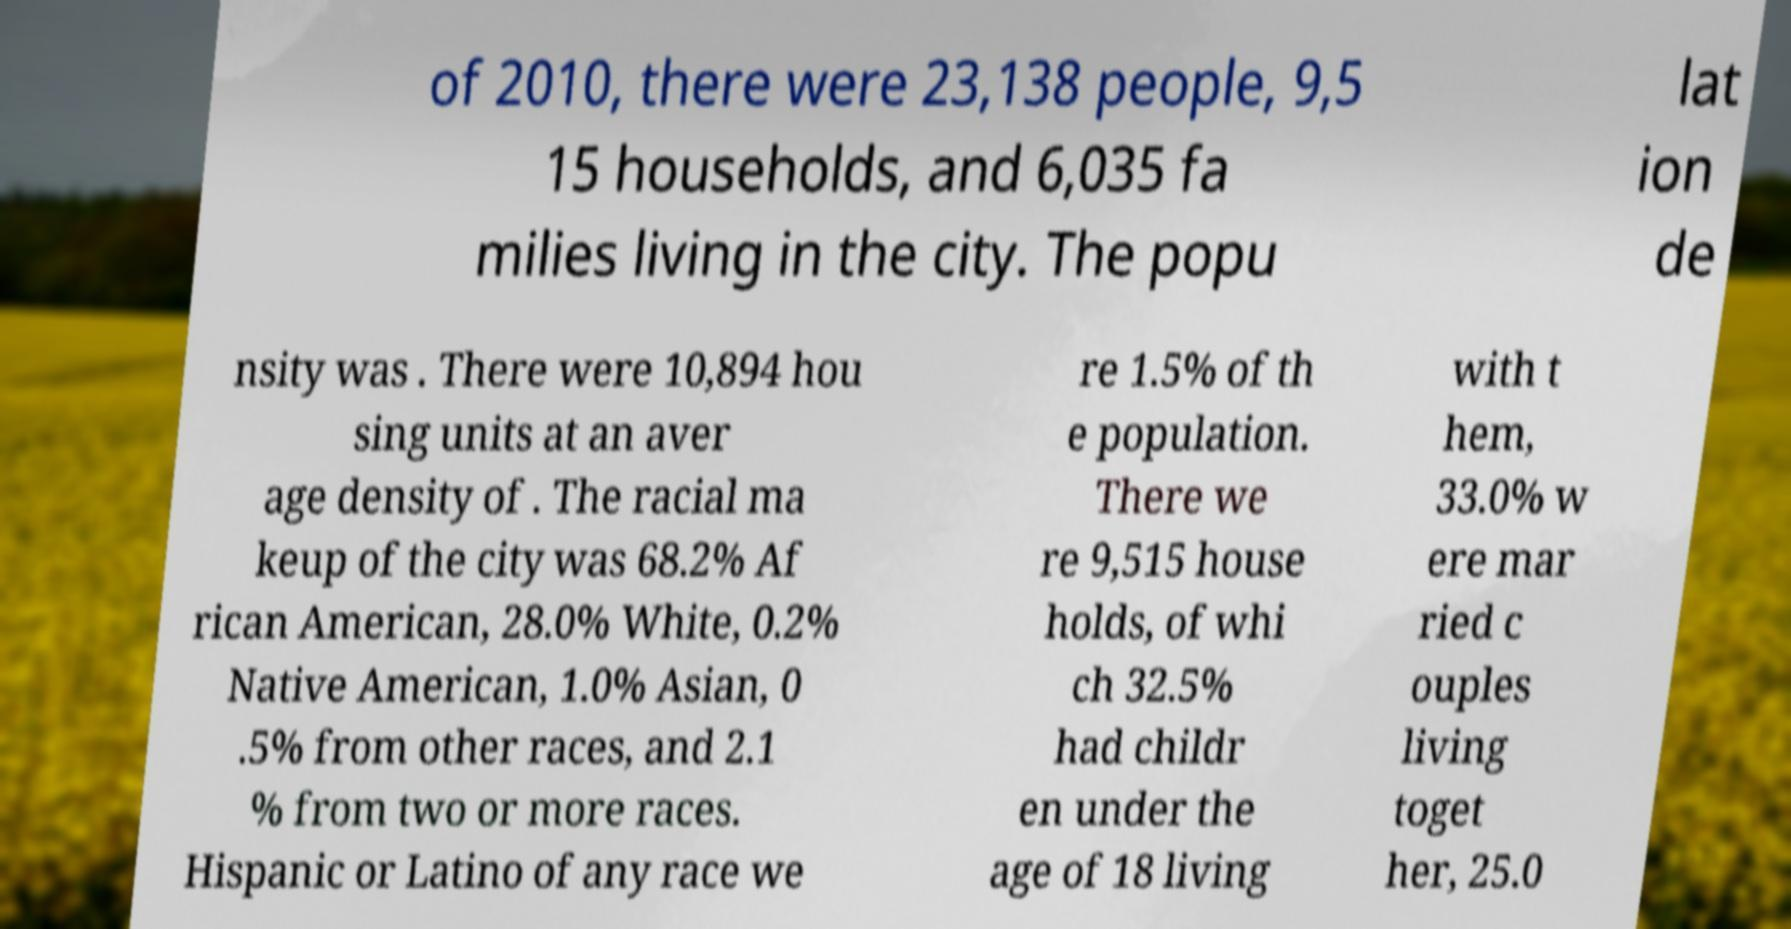Can you accurately transcribe the text from the provided image for me? of 2010, there were 23,138 people, 9,5 15 households, and 6,035 fa milies living in the city. The popu lat ion de nsity was . There were 10,894 hou sing units at an aver age density of . The racial ma keup of the city was 68.2% Af rican American, 28.0% White, 0.2% Native American, 1.0% Asian, 0 .5% from other races, and 2.1 % from two or more races. Hispanic or Latino of any race we re 1.5% of th e population. There we re 9,515 house holds, of whi ch 32.5% had childr en under the age of 18 living with t hem, 33.0% w ere mar ried c ouples living toget her, 25.0 